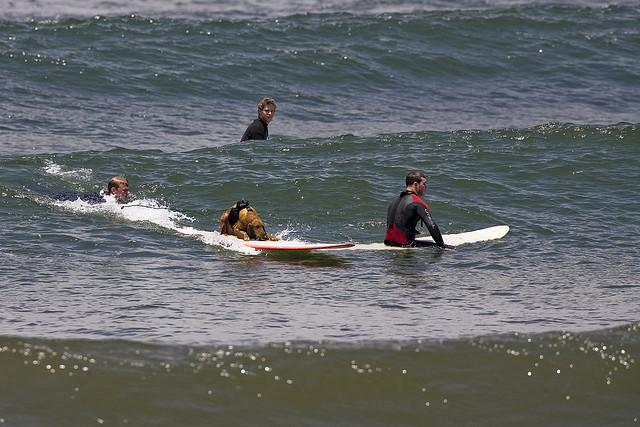What is the dog doing? surfing 